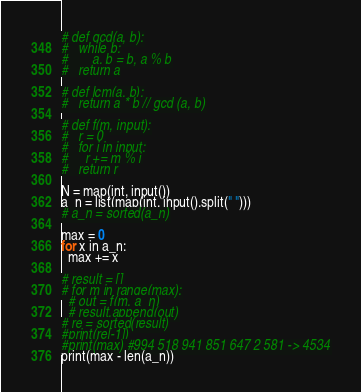Convert code to text. <code><loc_0><loc_0><loc_500><loc_500><_Python_># def gcd(a, b):
# 	while b:
# 		a, b = b, a % b
# 	return a

# def lcm(a, b):
# 	return a * b // gcd (a, b)

# def f(m, input):
#   r = 0
#   for i in input:
#     r += m % i
#   return r

N = map(int, input())
a_n = list(map(int, input().split(" ")))
# a_n = sorted(a_n)

max = 0
for x in a_n:
  max += x
 
# result = []
# for m in range(max):
  # out = f(m, a_n)
  # result.append(out)
# re = sorted(result)
#print(re[-1])
#print(max) #994 518 941 851 647 2 581 -> 4534
print(max - len(a_n))</code> 